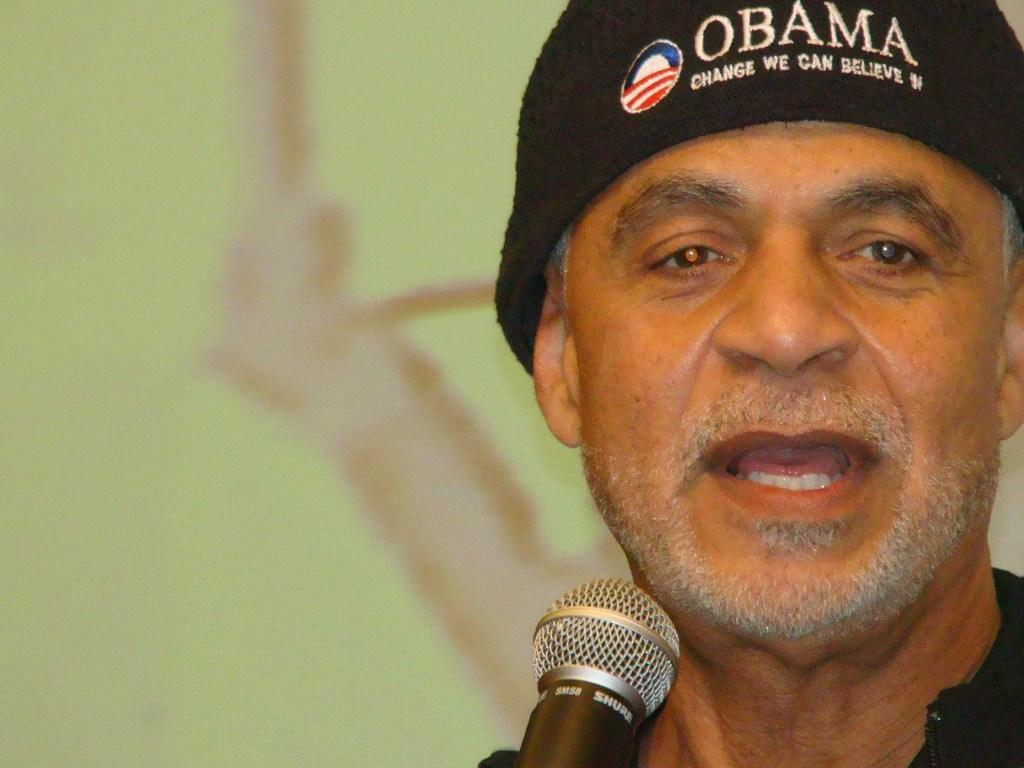Who is the main subject in the image? There is a man in the image. What is the man doing in the image? The man is speaking in the image. What object is in front of the man? There is a microphone in front of the man. Can you describe the background of the image? The background of the image is blurry. Is there a wound visible on the man's face in the image? There is no mention of a wound on the man's face in the image. 